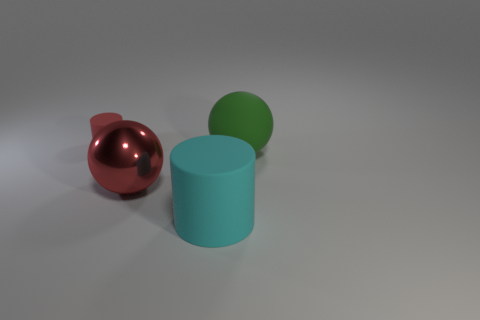What number of other big cyan cylinders are the same material as the large cyan cylinder?
Your answer should be very brief. 0. There is a big object that is on the right side of the rubber cylinder in front of the big matte thing that is behind the big cyan cylinder; what is its material?
Ensure brevity in your answer.  Rubber. There is a matte thing that is in front of the red object in front of the big green thing; what is its color?
Make the answer very short. Cyan. What color is the other shiny object that is the same size as the cyan object?
Your response must be concise. Red. What number of big things are either red shiny cubes or balls?
Give a very brief answer. 2. Is the number of big red objects that are left of the cyan matte object greater than the number of big shiny balls that are on the right side of the big shiny ball?
Your answer should be very brief. Yes. The shiny sphere that is the same color as the small matte cylinder is what size?
Give a very brief answer. Large. What number of other objects are there of the same size as the red metal sphere?
Your answer should be compact. 2. Does the object that is behind the green thing have the same material as the green object?
Ensure brevity in your answer.  Yes. How many other things are the same color as the big rubber ball?
Provide a short and direct response. 0. 